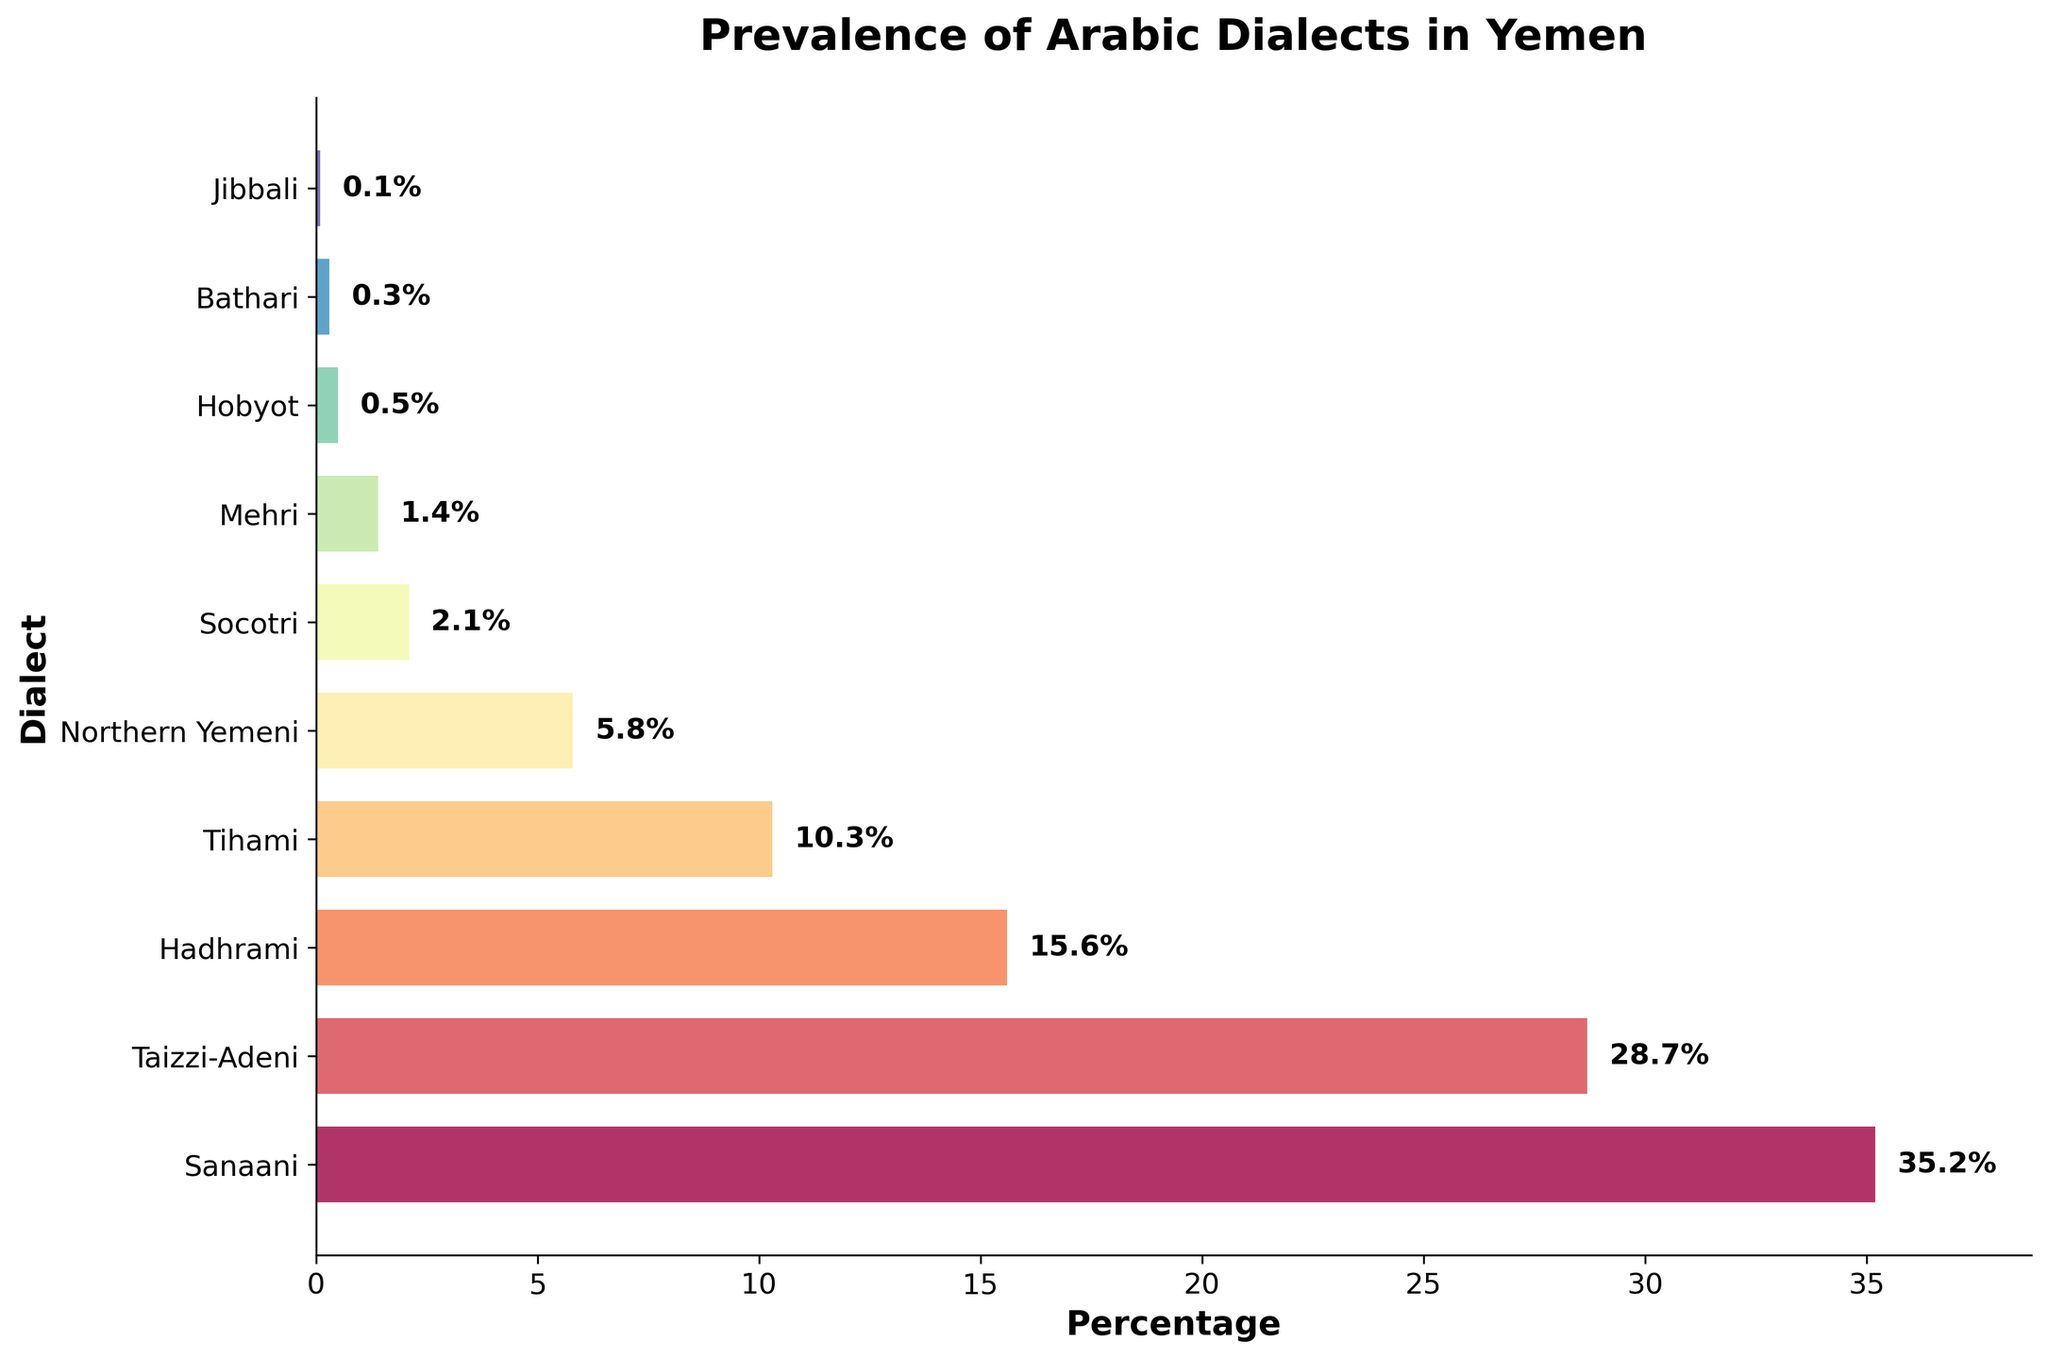What is the title of the figure? The title is located at the top of the figure. It is usually in larger and bold font to make it stand out.
Answer: Prevalence of Arabic Dialects in Yemen Which dialect has the highest percentage? Look for the longest bar on the plot, which indicates the highest percentage.
Answer: Sanaani What is the percentage of Taizzi-Adeni dialect? Identify the bar corresponding to Taizzi-Adeni and check the percentage value next to it.
Answer: 28.7% How many dialects have a percentage greater than 10%? Count the bars with percentages greater than 10%.
Answer: Four What is the difference in percentage between Hadhrami and Tihami dialects? Subtract the percentage of Tihami from that of Hadhrami.
Answer: 15.6% - 10.3% = 5.3% What is the total percentage of the top three most spoken dialects? Sum the percentages of the three longest bars representing the top three dialects.
Answer: 35.2% + 28.7% + 15.6% = 79.5% Which dialect is least spoken and what is its percentage? Identify the shortest bar on the plot and read its percentage.
Answer: Jibbali, 0.1% How much more prevalent is Sanaani compared to Northern Yemeni? Subtract the percentage of Northern Yemeni from that of Sanaani.
Answer: 35.2% - 5.8% = 29.4% Are there any dialects with a percentage below 1%? If yes, name them. Check the bars with percentages less than 1% and list their names.
Answer: Yes, Hobyot, Bathari, Jibbali 